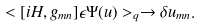<formula> <loc_0><loc_0><loc_500><loc_500>< [ i H , g _ { m n } ] \epsilon \Psi ( u ) > _ { q } \rightarrow \delta u _ { m n } .</formula> 